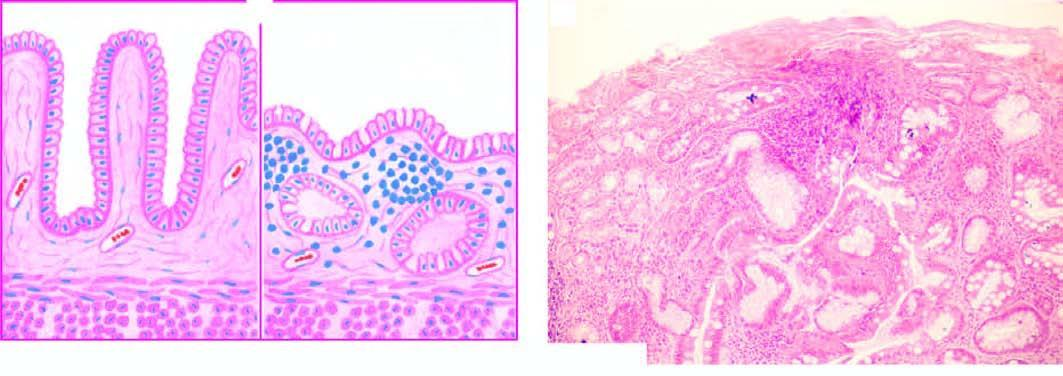s the silicotic nodule marked gastric atrophy with disappearance of gastric glands and appearance of goblet cells intestinal metaplasia?
Answer the question using a single word or phrase. No 